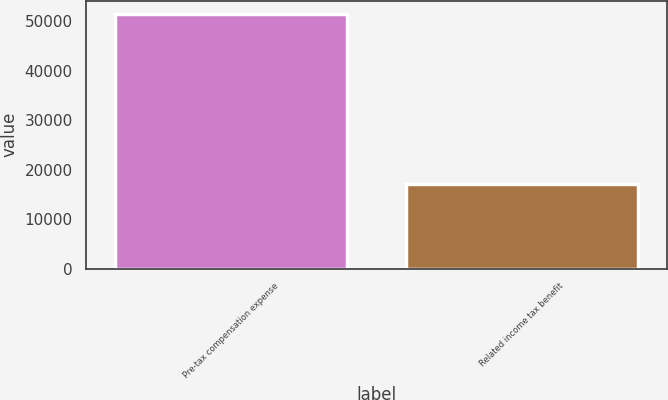<chart> <loc_0><loc_0><loc_500><loc_500><bar_chart><fcel>Pre-tax compensation expense<fcel>Related income tax benefit<nl><fcel>51533<fcel>17109<nl></chart> 